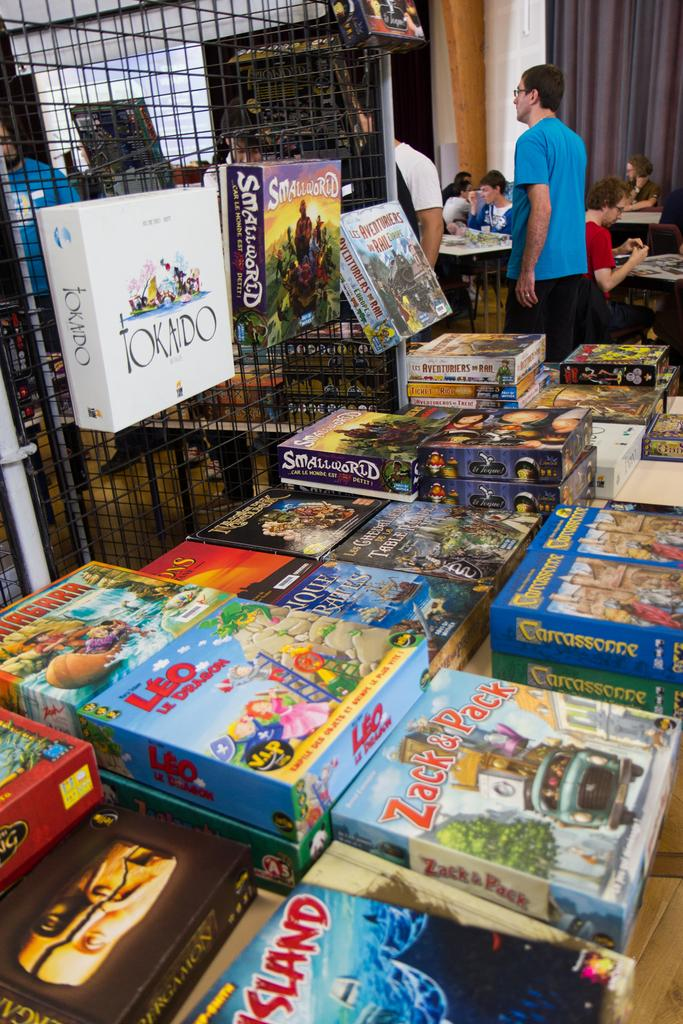Provide a one-sentence caption for the provided image. A Tokaido board game box is shown along with dozens of other games. 